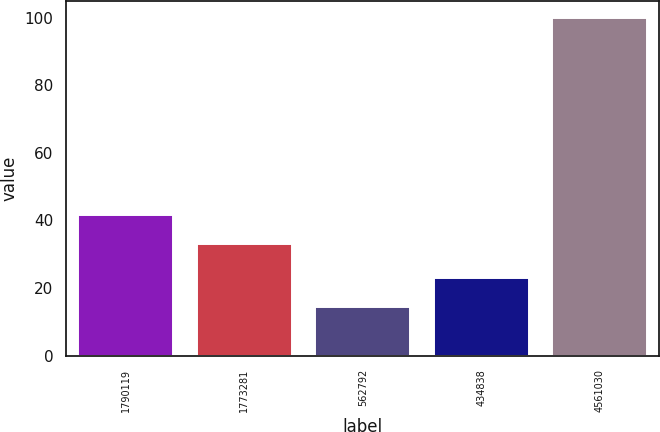Convert chart. <chart><loc_0><loc_0><loc_500><loc_500><bar_chart><fcel>1790119<fcel>1773281<fcel>562792<fcel>434838<fcel>4561030<nl><fcel>41.45<fcel>32.9<fcel>14.5<fcel>23.05<fcel>100<nl></chart> 